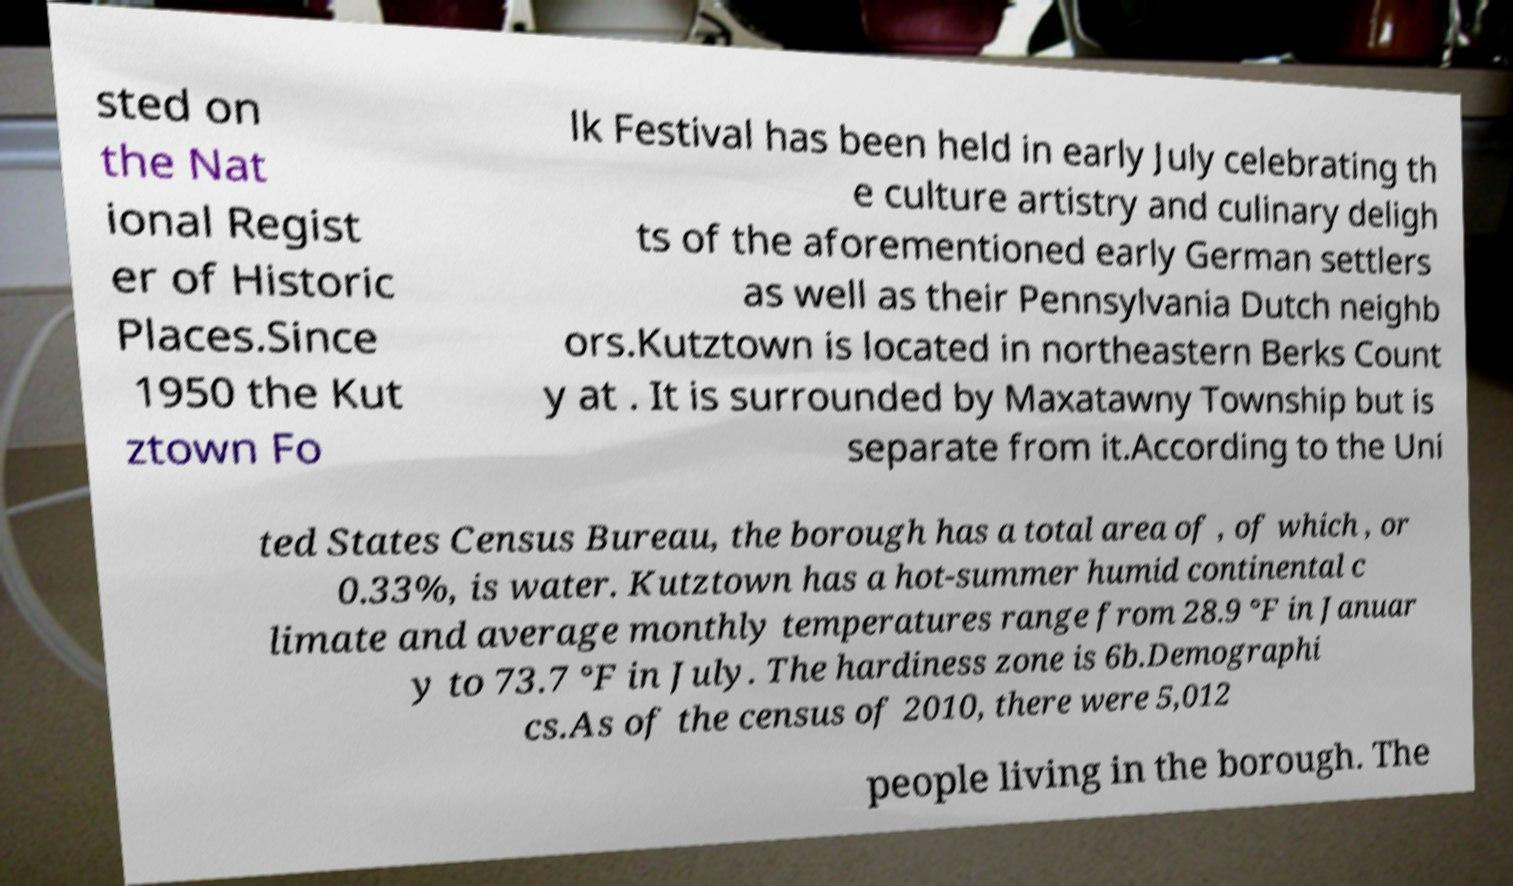Can you read and provide the text displayed in the image?This photo seems to have some interesting text. Can you extract and type it out for me? sted on the Nat ional Regist er of Historic Places.Since 1950 the Kut ztown Fo lk Festival has been held in early July celebrating th e culture artistry and culinary deligh ts of the aforementioned early German settlers as well as their Pennsylvania Dutch neighb ors.Kutztown is located in northeastern Berks Count y at . It is surrounded by Maxatawny Township but is separate from it.According to the Uni ted States Census Bureau, the borough has a total area of , of which , or 0.33%, is water. Kutztown has a hot-summer humid continental c limate and average monthly temperatures range from 28.9 °F in Januar y to 73.7 °F in July. The hardiness zone is 6b.Demographi cs.As of the census of 2010, there were 5,012 people living in the borough. The 